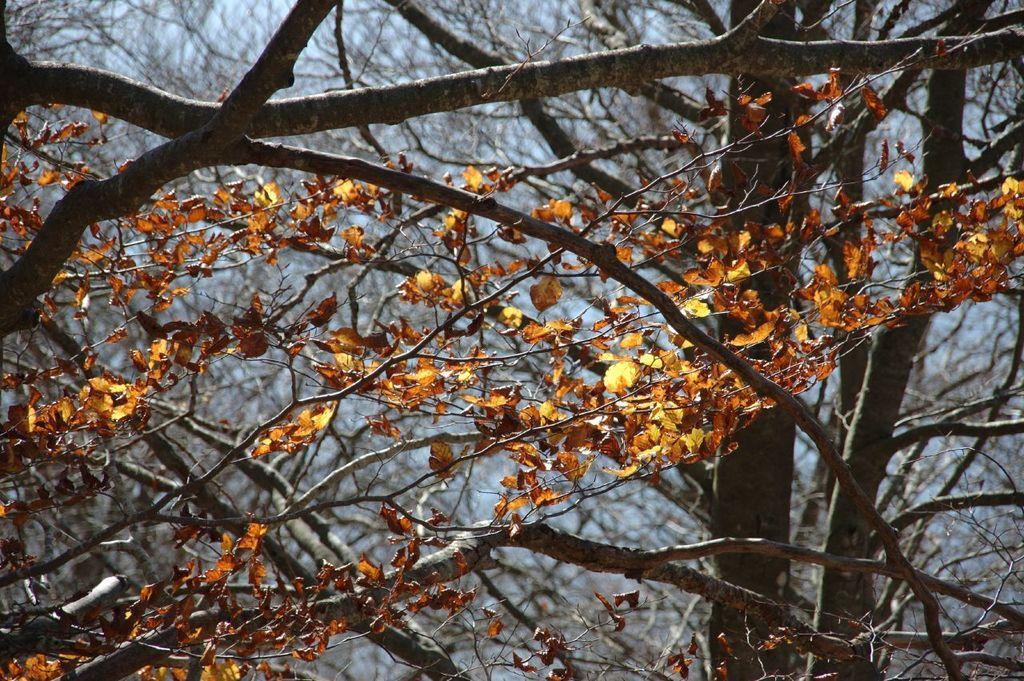Could you give a brief overview of what you see in this image? In this image we can see some branches of a tree with some leaves. We can also see the sky. 